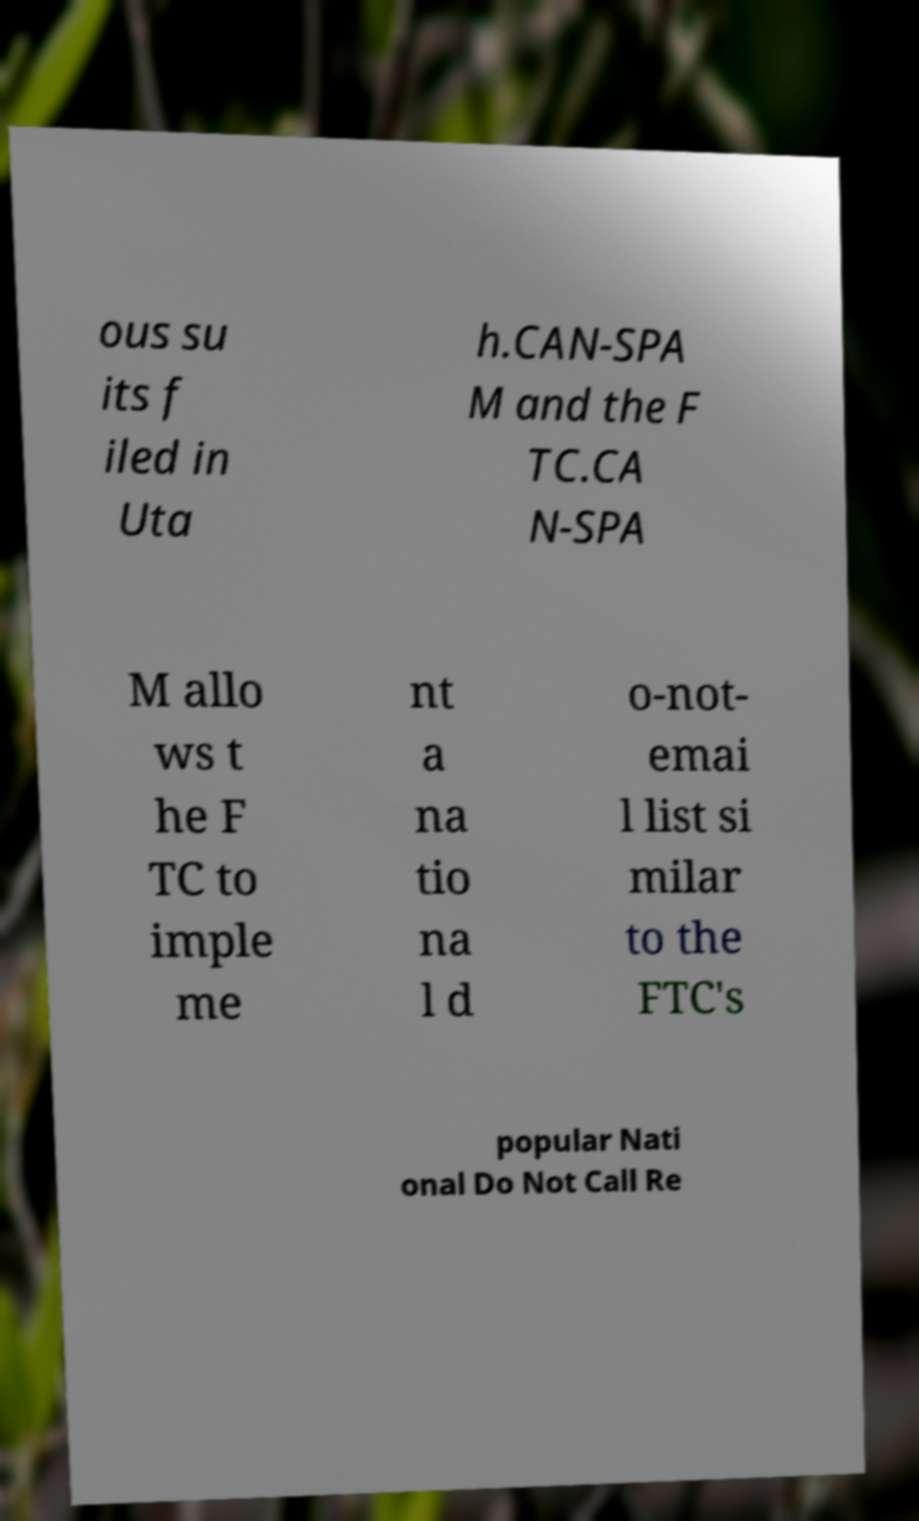Can you accurately transcribe the text from the provided image for me? ous su its f iled in Uta h.CAN-SPA M and the F TC.CA N-SPA M allo ws t he F TC to imple me nt a na tio na l d o-not- emai l list si milar to the FTC's popular Nati onal Do Not Call Re 